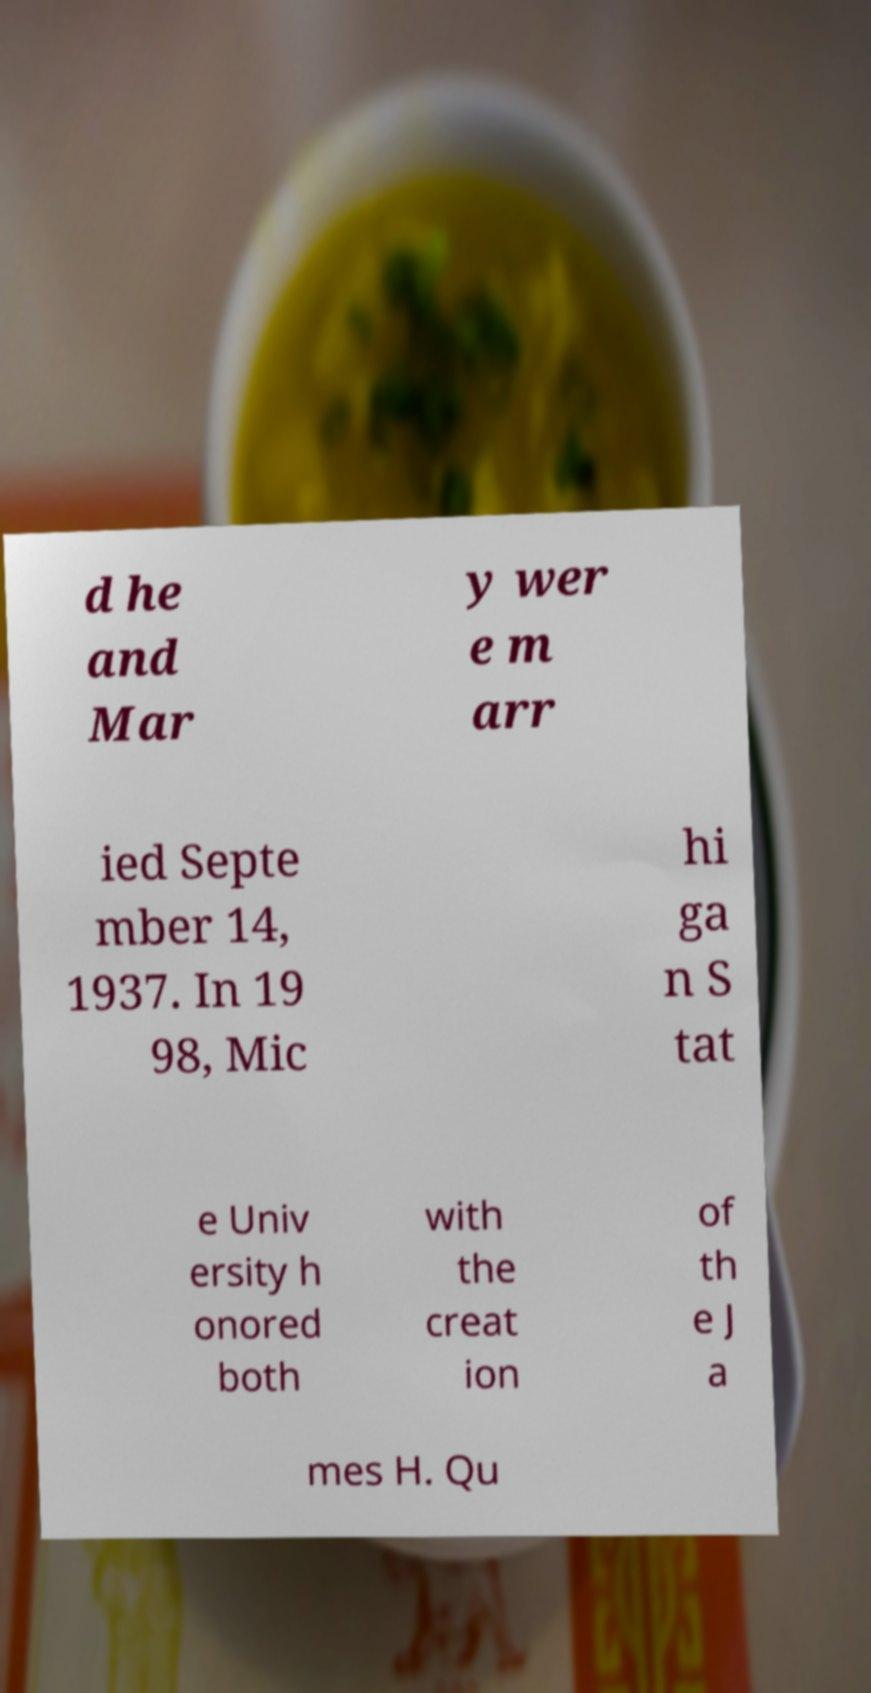Please identify and transcribe the text found in this image. d he and Mar y wer e m arr ied Septe mber 14, 1937. In 19 98, Mic hi ga n S tat e Univ ersity h onored both with the creat ion of th e J a mes H. Qu 